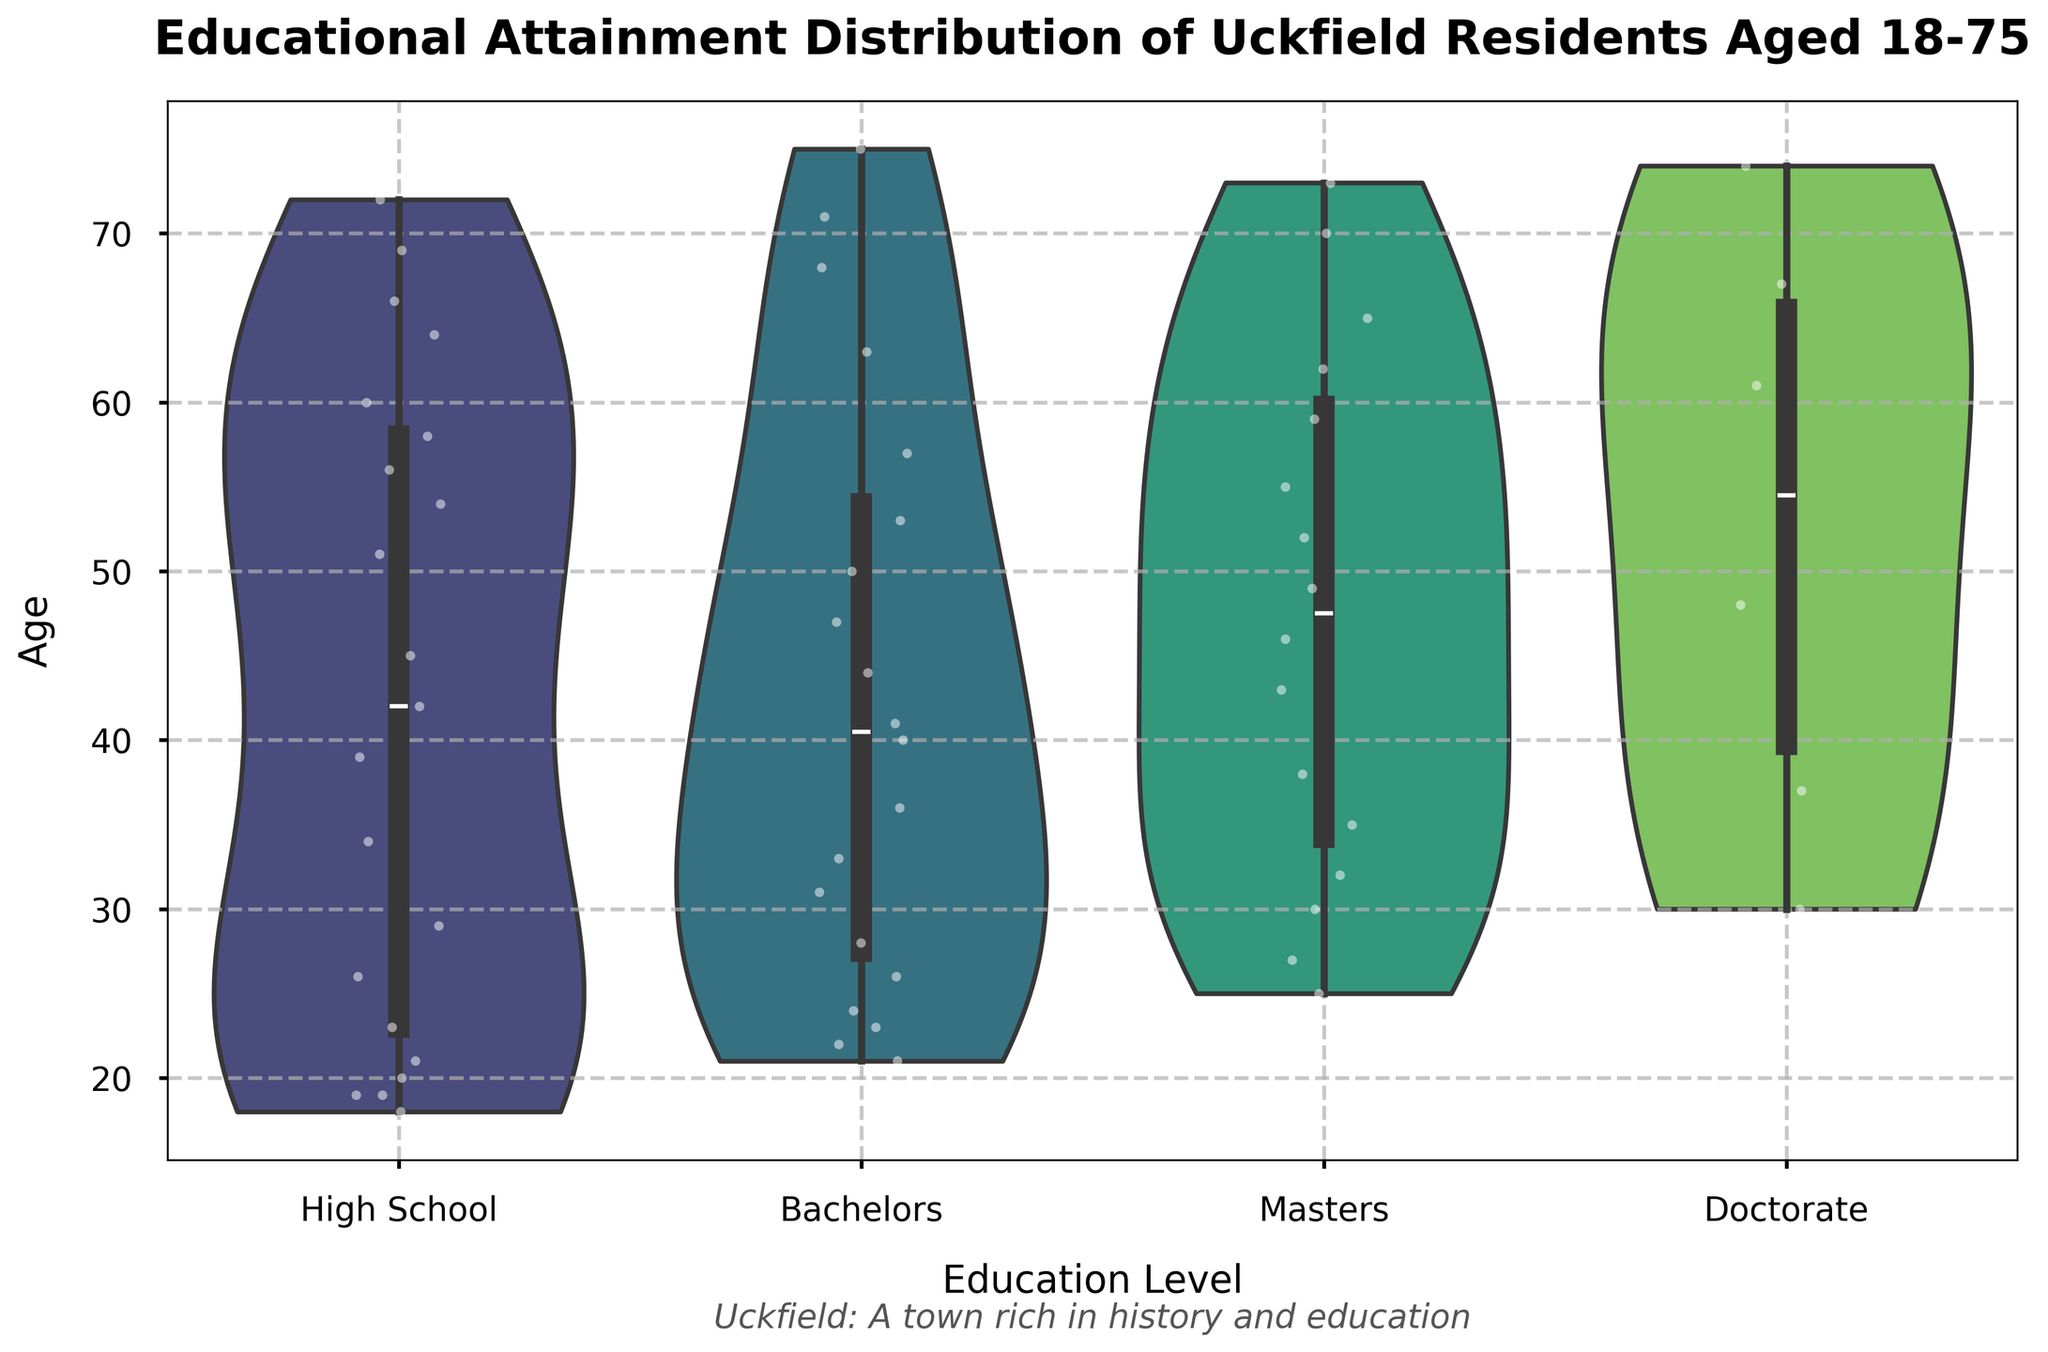What is the title of the violin plot? The title text is displayed at the top of the figure in a larger, bold font which reads "Educational Attainment Distribution of Uckfield Residents Aged 18-75".
Answer: Educational Attainment Distribution of Uckfield Residents Aged 18-75 Which education level has the widest age range? By observing the range of ages within each violin plot, the 'High School' category shows ages spanning from 18 to 75, which is the widest range among all categories.
Answer: High School What is the median age for residents with a Doctorate? The median age can be identified by the central line within the 'Doctorate' violin plot, which is located around age 49.
Answer: 49 Which education level has the most residents in the age group 30-40? Looking at the distribution of dots between ages 30 and 40 in the plots, the 'Bachelors' category has the most data points within this age range.
Answer: Bachelors Are there more residents aged over 60 with a Bachelors or a Doctorate? By comparing the number of data points above age 60 in the 'Bachelors' and 'Doctorate' categories, it is clear that there are more data points for 'Bachelors'.
Answer: Bachelors What can we say about the distribution shape of residents with a Masters degree? Observing the shape of the 'Masters' violin plot, it shows a relatively even distribution with a slight peak around the ages of 35-45.
Answer: Even with a slight peak around 35-45 Which education level has the highest density of young adults (ages 18-25)? Examining the density of points within the age range 18-25, the 'High School' category has the highest density.
Answer: High School Which age group has the least variation in educational attainment? The age group 67-75 appears to have lesser variation in education levels, mostly falling under 'High School' and 'Masters' categories.
Answer: 67-75 Can we observe a significant number of Doctorate holders in younger age groups? By checking the 'Doctorate' category, there are fewer data points in the younger age groups (18-30), indicating fewer Doctorate holders among younger residents.
Answer: No 